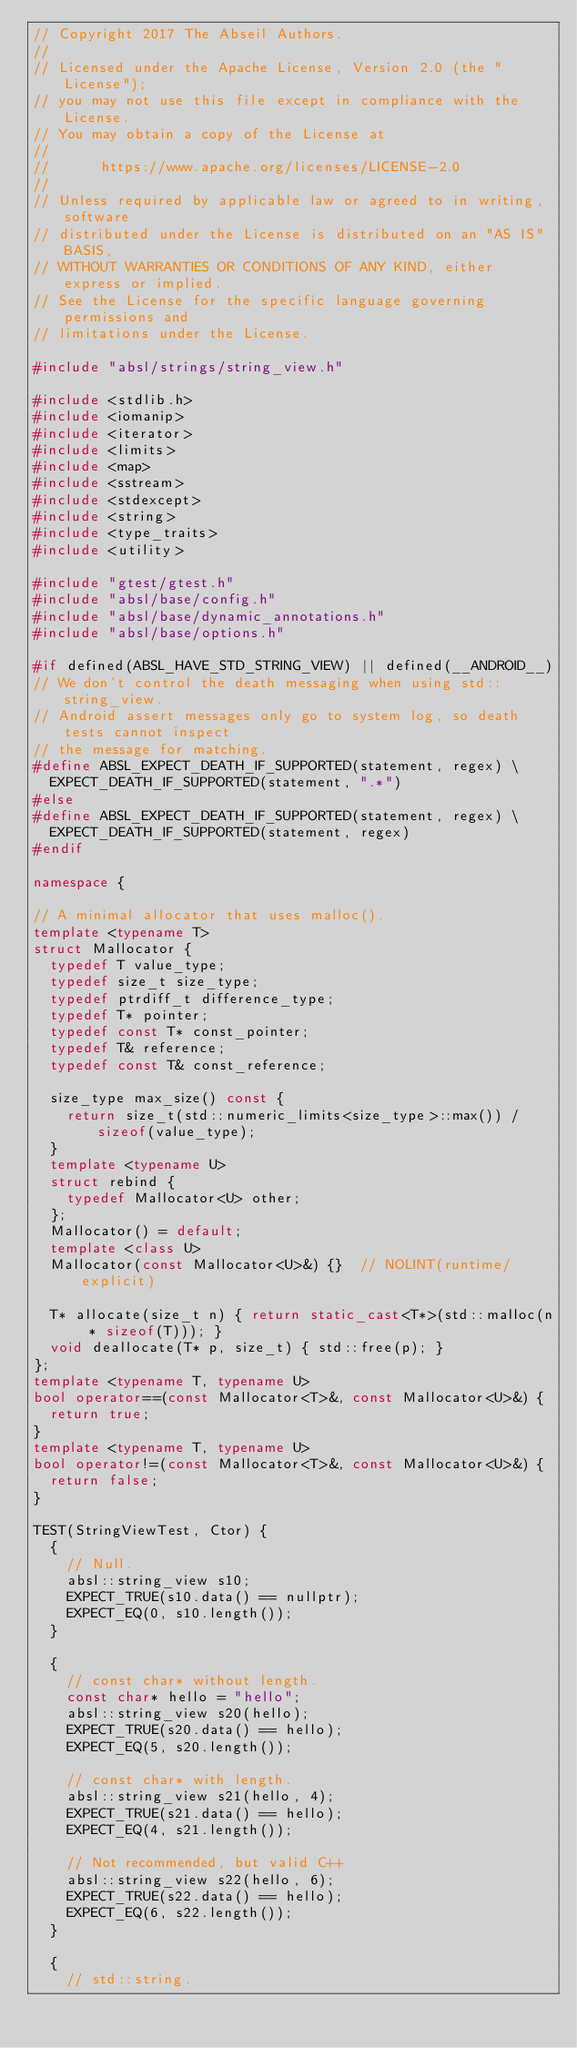<code> <loc_0><loc_0><loc_500><loc_500><_C++_>// Copyright 2017 The Abseil Authors.
//
// Licensed under the Apache License, Version 2.0 (the "License");
// you may not use this file except in compliance with the License.
// You may obtain a copy of the License at
//
//      https://www.apache.org/licenses/LICENSE-2.0
//
// Unless required by applicable law or agreed to in writing, software
// distributed under the License is distributed on an "AS IS" BASIS,
// WITHOUT WARRANTIES OR CONDITIONS OF ANY KIND, either express or implied.
// See the License for the specific language governing permissions and
// limitations under the License.

#include "absl/strings/string_view.h"

#include <stdlib.h>
#include <iomanip>
#include <iterator>
#include <limits>
#include <map>
#include <sstream>
#include <stdexcept>
#include <string>
#include <type_traits>
#include <utility>

#include "gtest/gtest.h"
#include "absl/base/config.h"
#include "absl/base/dynamic_annotations.h"
#include "absl/base/options.h"

#if defined(ABSL_HAVE_STD_STRING_VIEW) || defined(__ANDROID__)
// We don't control the death messaging when using std::string_view.
// Android assert messages only go to system log, so death tests cannot inspect
// the message for matching.
#define ABSL_EXPECT_DEATH_IF_SUPPORTED(statement, regex) \
  EXPECT_DEATH_IF_SUPPORTED(statement, ".*")
#else
#define ABSL_EXPECT_DEATH_IF_SUPPORTED(statement, regex) \
  EXPECT_DEATH_IF_SUPPORTED(statement, regex)
#endif

namespace {

// A minimal allocator that uses malloc().
template <typename T>
struct Mallocator {
  typedef T value_type;
  typedef size_t size_type;
  typedef ptrdiff_t difference_type;
  typedef T* pointer;
  typedef const T* const_pointer;
  typedef T& reference;
  typedef const T& const_reference;

  size_type max_size() const {
    return size_t(std::numeric_limits<size_type>::max()) / sizeof(value_type);
  }
  template <typename U>
  struct rebind {
    typedef Mallocator<U> other;
  };
  Mallocator() = default;
  template <class U>
  Mallocator(const Mallocator<U>&) {}  // NOLINT(runtime/explicit)

  T* allocate(size_t n) { return static_cast<T*>(std::malloc(n * sizeof(T))); }
  void deallocate(T* p, size_t) { std::free(p); }
};
template <typename T, typename U>
bool operator==(const Mallocator<T>&, const Mallocator<U>&) {
  return true;
}
template <typename T, typename U>
bool operator!=(const Mallocator<T>&, const Mallocator<U>&) {
  return false;
}

TEST(StringViewTest, Ctor) {
  {
    // Null.
    absl::string_view s10;
    EXPECT_TRUE(s10.data() == nullptr);
    EXPECT_EQ(0, s10.length());
  }

  {
    // const char* without length.
    const char* hello = "hello";
    absl::string_view s20(hello);
    EXPECT_TRUE(s20.data() == hello);
    EXPECT_EQ(5, s20.length());

    // const char* with length.
    absl::string_view s21(hello, 4);
    EXPECT_TRUE(s21.data() == hello);
    EXPECT_EQ(4, s21.length());

    // Not recommended, but valid C++
    absl::string_view s22(hello, 6);
    EXPECT_TRUE(s22.data() == hello);
    EXPECT_EQ(6, s22.length());
  }

  {
    // std::string.</code> 